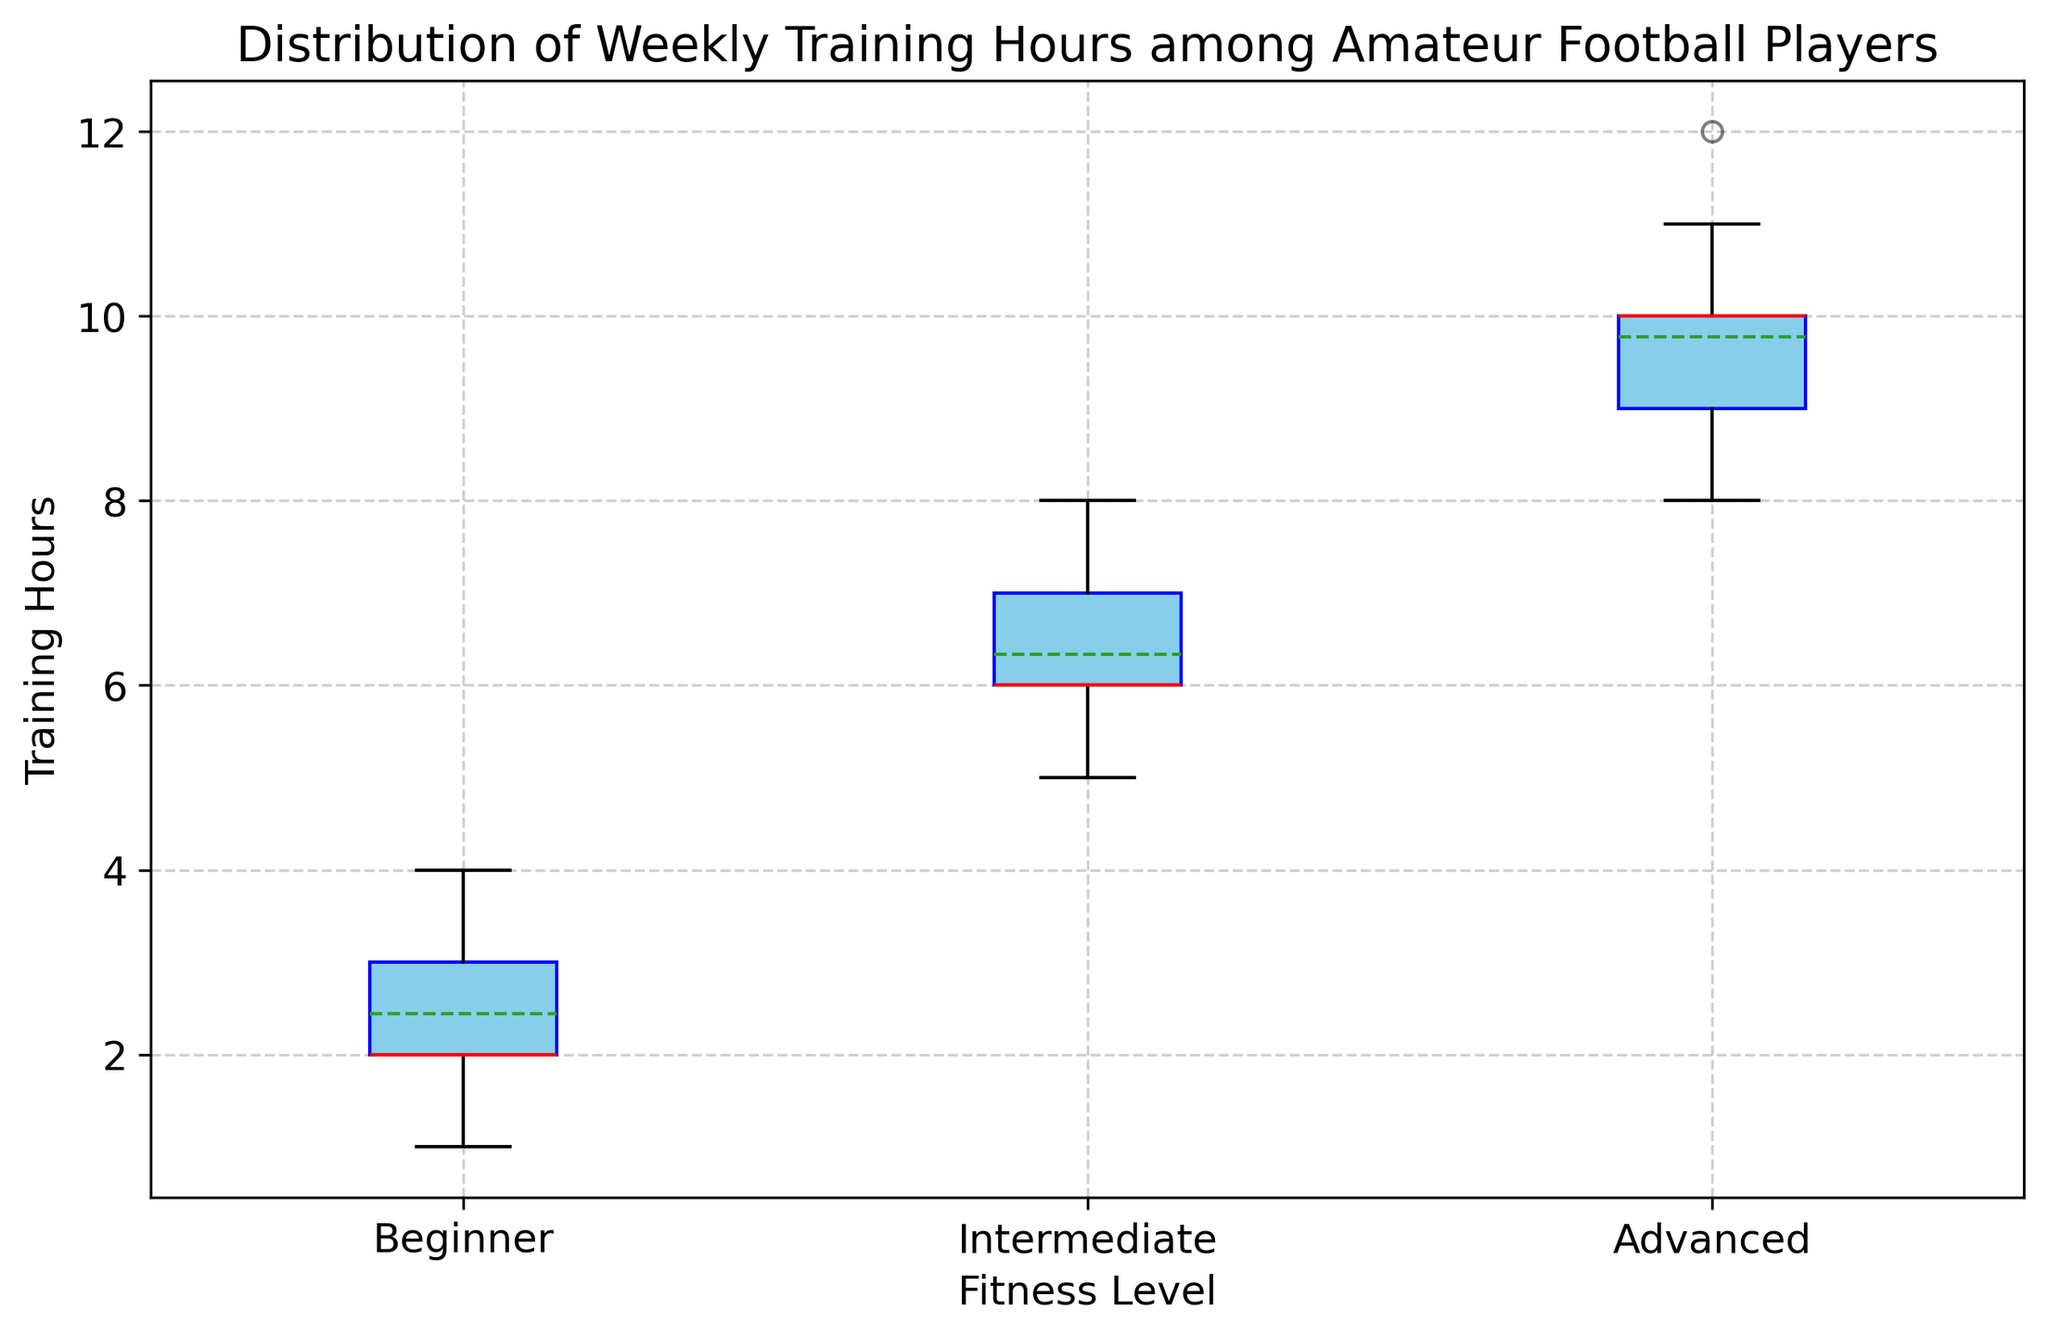What is the median value for Intermediate fitness level? The median is the middle value when the data points are ordered, so for Intermediate: ordered data [5, 5, 6, 6, 6, 7, 7, 7, 8], the middle value is 6.
Answer: 6 What is the range of training hours for Advanced fitness level? The range is calculated as the difference between the maximum and minimum values. For Advanced: max = 12, min = 8, range = 12 - 8.
Answer: 4 Which fitness level has the highest median training hours? Compare the median values of Beginner (2), Intermediate (6), and Advanced (10); Advanced has the highest median.
Answer: Advanced Which fitness level group shows the most variability in training hours? The most variability is observed in the group with the longest whiskers or widest box. Here, the Intermediate group has more variability compared to Beginner and Advanced, as the box and whiskers are relatively longer.
Answer: Intermediate Which fitness level group has the lowest interquartile range (IQR)? The IQR is the difference between Q3 and Q1. The Beginner group, with Q1 (2) and Q3 (3), has the lowest IQR compared to Intermediate (Q1: 6, Q3: 7) and Advanced (Q1: 9, Q3: 10).
Answer: Beginner How does the median training hours of Intermediate compare to the mean training hours of Beginner? Median of Intermediate (6) > Mean of Beginner (2.44).
Answer: Median of Intermediate is greater What is the most common training hours value for Advanced fitness level? Look at the mode or the most frequent value in Advanced group: 9 and 10 appear multiple times, making them the most common values.
Answer: 9 and 10 How does the mean training hours for Intermediate fitness level compare with the mean training hours for Advanced fitness level? Compare means for Intermediate (6.33) and Advanced (9.78); the Advanced group's mean is higher.
Answer: Advanced group's mean is higher Are there any outliers in the Beginner fitness level's training hours, and if so, what are they? Outliers are points that fall outside the whiskers. Here, Beginner has data points within the whiskers' range (1-4), so there are no visible outliers.
Answer: No 